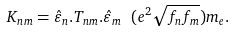Convert formula to latex. <formula><loc_0><loc_0><loc_500><loc_500>K _ { n m } = \hat { \varepsilon } _ { n } . T _ { n m } . \hat { \varepsilon } _ { m } \ ( e ^ { 2 } \sqrt { f _ { n } f _ { m } } ) m _ { e } . \</formula> 